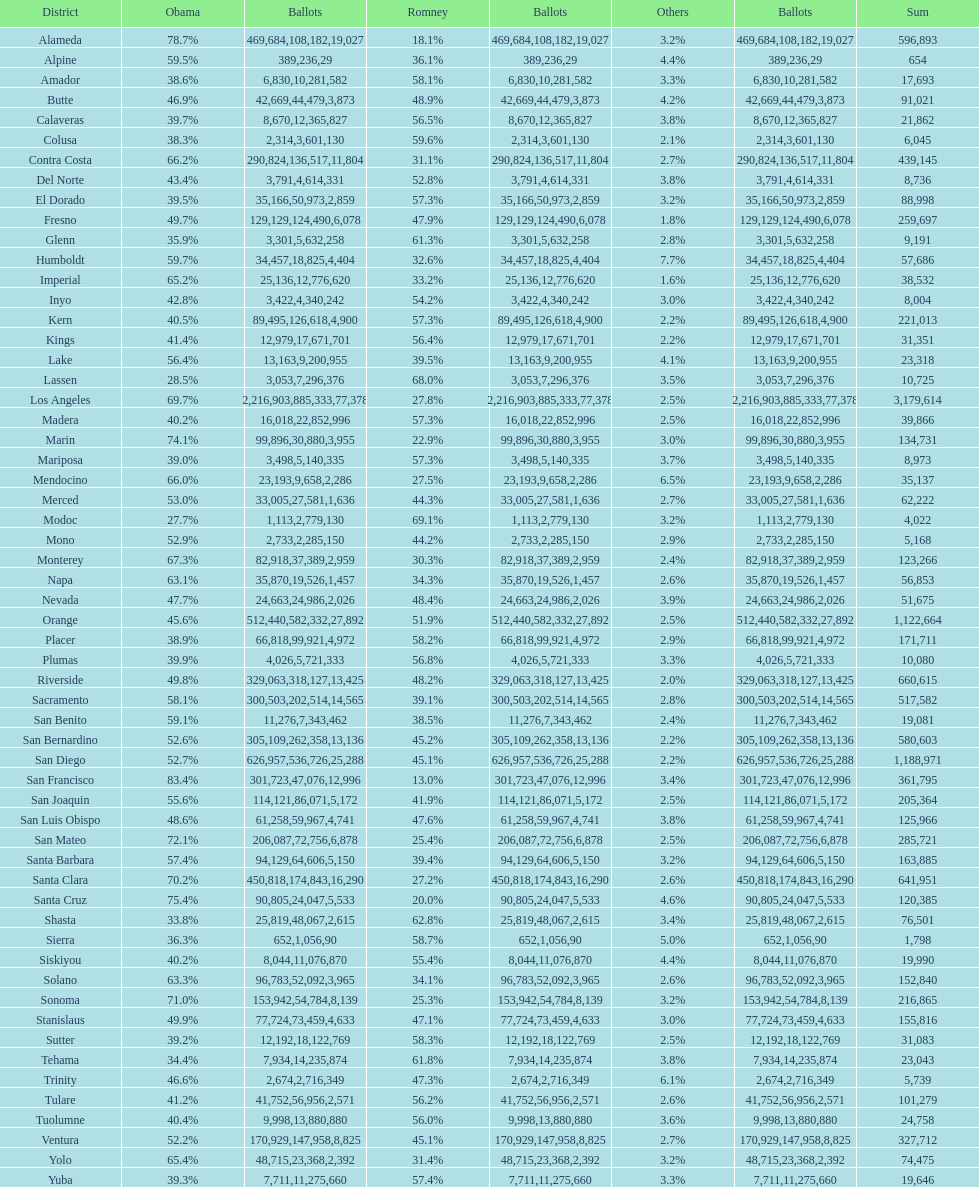How many counties had at least 75% of the votes for obama? 3. 